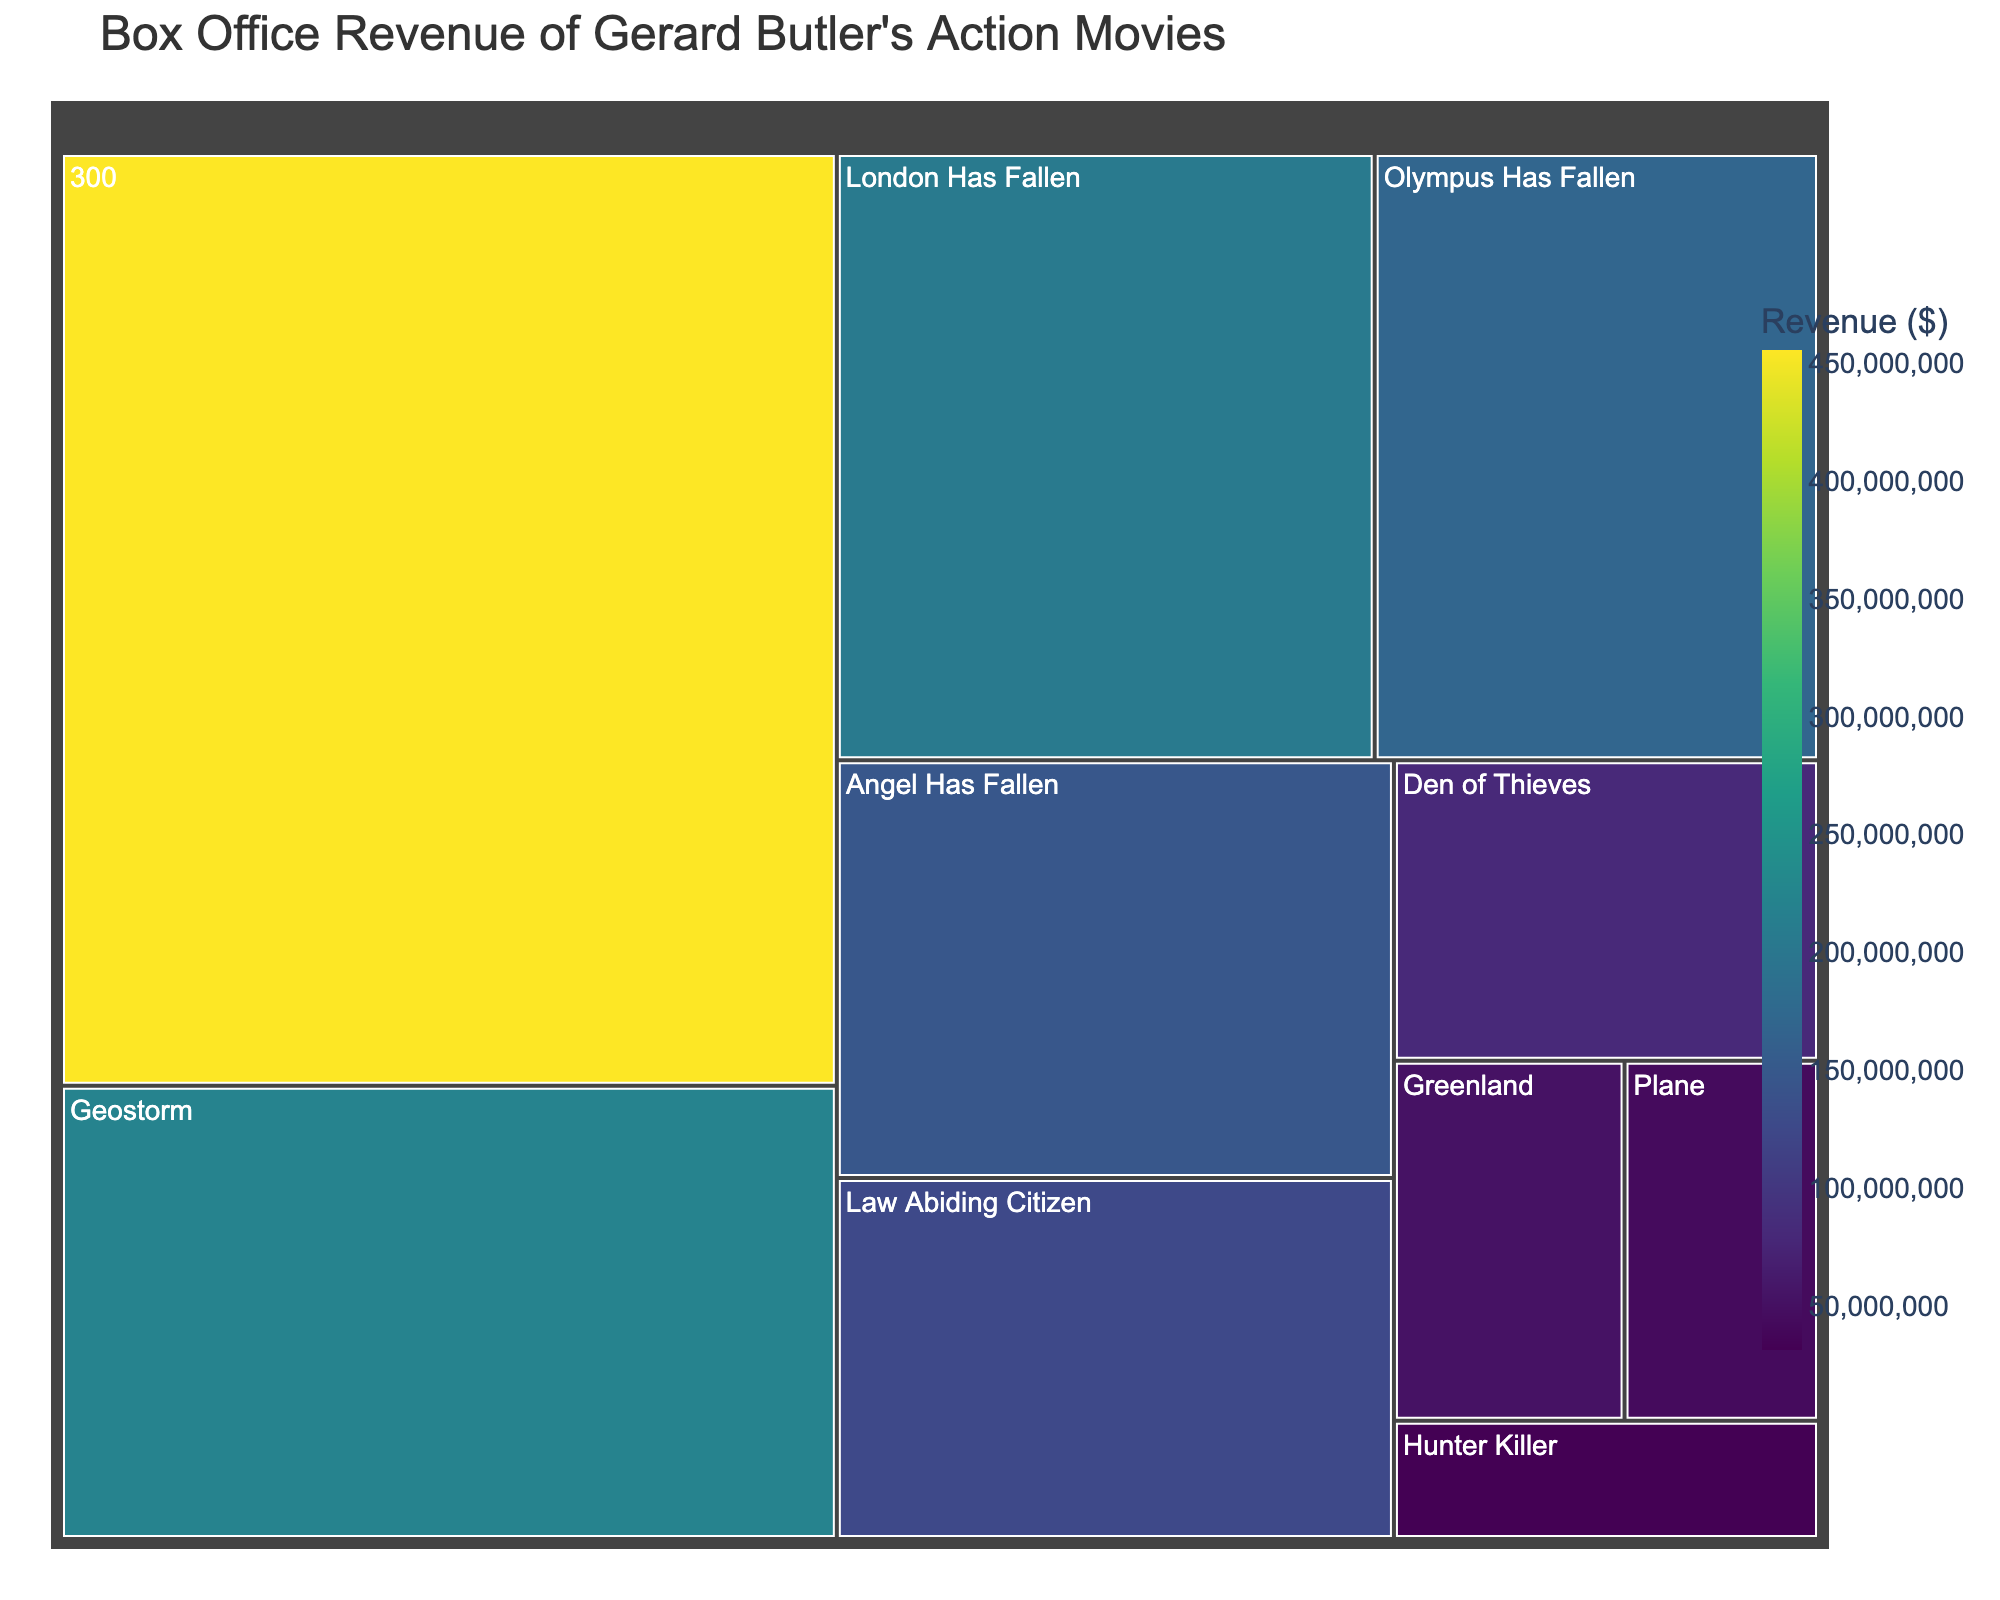What is the title of the treemap? The title is typically located at the top of the figure. The title in this case is "Box Office Revenue of Gerard Butler's Action Movies."
Answer: Box Office Revenue of Gerard Butler's Action Movies Which Gerard Butler action movie generated the highest box office revenue? The largest box in the treemap, which represents the movie with the highest revenue, is "300."
Answer: 300 How much box office revenue did "Geostorm" generate? By locating "Geostorm" in the treemap and observing its associated value, we can find the revenue. The hover data indicates the value directly.
Answer: $221,600,000 Which movie generated less revenue, "Den of Thieves" or "Plane"? To compare the two movies, we find both in the treemap. Observing their respective sizes and the values, we see "Den of Thieves" generated $80,500,000 while "Plane" generated $44,100,000.
Answer: Plane What is the total box office revenue of the top three highest-grossing Gerard Butler action movies? The top three highest-grossing movies are "300" ($456,000,000), "Geostorm" ($221,600,000), and "London Has Fallen" ($205,800,000). Adding these together: $456,000,000 + $221,600,000 + $205,800,000 = $883,400,000.
Answer: $883,400,000 Which has a higher revenue: "Angel Has Fallen" or "Olympus Has Fallen"? By comparing the sizes and values of the boxes for "Angel Has Fallen" and "Olympus Has Fallen," we can see "Olympus Has Fallen" generated $170,000,000 whereas "Angel Has Fallen" generated $146,700,000.
Answer: Olympus Has Fallen What is the approximate median revenue of all the movies shown in the treemap? Arrange the revenues numerically: $31,700,000, $44,100,000, $52,300,000, $80,500,000, $126,700,000, $146,700,000, $170,000,000, $205,800,000, $221,600,000, $456,000,000. The median is the middle value of this ordered list, which is $126,700,000.
Answer: $126,700,000 What are the two lowest-grossing movies? By examining the two smallest boxes in the treemap, these represent "Plane" ($44,100,000) and "Hunter Killer" ($31,700,000).
Answer: Hunter Killer and Plane What percentage of the revenue did "Olympus Has Fallen" make relative to "300"? The revenue of "Olympus Has Fallen" ($170,000,000) relative to "300" ($456,000,000) is calculated as ($170,000,000 / $456,000,000) * 100 ≈ 37.28%.
Answer: Approximately 37.28% 